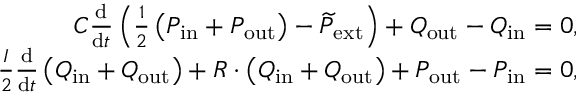Convert formula to latex. <formula><loc_0><loc_0><loc_500><loc_500>\begin{array} { r } { C \frac { d } { d t } \left ( \frac { 1 } { 2 } \left ( P _ { i n } + P _ { o u t } \right ) - \widetilde { P } _ { e x t } \right ) + Q _ { o u t } - Q _ { i n } = 0 , } \\ { \frac { I } { 2 } \frac { d } { d t } \left ( Q _ { i n } + Q _ { o u t } \right ) + R \cdot \left ( Q _ { i n } + Q _ { o u t } \right ) + P _ { o u t } - P _ { i n } = 0 , } \end{array}</formula> 